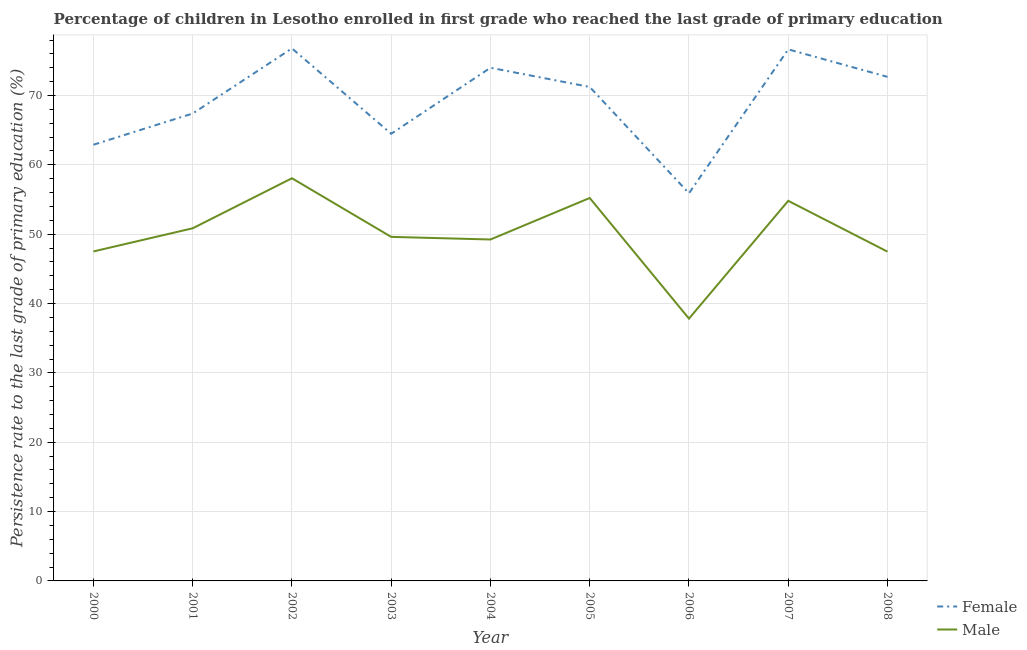Does the line corresponding to persistence rate of male students intersect with the line corresponding to persistence rate of female students?
Provide a short and direct response. No. Is the number of lines equal to the number of legend labels?
Your answer should be very brief. Yes. What is the persistence rate of male students in 2003?
Provide a succinct answer. 49.61. Across all years, what is the maximum persistence rate of female students?
Provide a succinct answer. 76.79. Across all years, what is the minimum persistence rate of female students?
Make the answer very short. 55.9. In which year was the persistence rate of male students maximum?
Your answer should be compact. 2002. In which year was the persistence rate of female students minimum?
Your response must be concise. 2006. What is the total persistence rate of female students in the graph?
Your response must be concise. 622.06. What is the difference between the persistence rate of male students in 2000 and that in 2008?
Keep it short and to the point. 0.03. What is the difference between the persistence rate of female students in 2004 and the persistence rate of male students in 2006?
Make the answer very short. 36.18. What is the average persistence rate of male students per year?
Provide a short and direct response. 50.07. In the year 2008, what is the difference between the persistence rate of female students and persistence rate of male students?
Your response must be concise. 25.2. In how many years, is the persistence rate of male students greater than 60 %?
Your answer should be compact. 0. What is the ratio of the persistence rate of female students in 2000 to that in 2008?
Your response must be concise. 0.87. Is the persistence rate of male students in 2002 less than that in 2003?
Provide a short and direct response. No. What is the difference between the highest and the second highest persistence rate of female students?
Your answer should be compact. 0.14. What is the difference between the highest and the lowest persistence rate of male students?
Give a very brief answer. 20.24. Does the persistence rate of female students monotonically increase over the years?
Provide a succinct answer. No. Is the persistence rate of male students strictly greater than the persistence rate of female students over the years?
Your answer should be very brief. No. Is the persistence rate of female students strictly less than the persistence rate of male students over the years?
Make the answer very short. No. How many years are there in the graph?
Make the answer very short. 9. What is the difference between two consecutive major ticks on the Y-axis?
Offer a very short reply. 10. Are the values on the major ticks of Y-axis written in scientific E-notation?
Give a very brief answer. No. Does the graph contain any zero values?
Your answer should be very brief. No. Where does the legend appear in the graph?
Offer a terse response. Bottom right. How many legend labels are there?
Make the answer very short. 2. What is the title of the graph?
Provide a short and direct response. Percentage of children in Lesotho enrolled in first grade who reached the last grade of primary education. Does "Investments" appear as one of the legend labels in the graph?
Your response must be concise. No. What is the label or title of the Y-axis?
Make the answer very short. Persistence rate to the last grade of primary education (%). What is the Persistence rate to the last grade of primary education (%) in Female in 2000?
Give a very brief answer. 62.9. What is the Persistence rate to the last grade of primary education (%) of Male in 2000?
Ensure brevity in your answer.  47.51. What is the Persistence rate to the last grade of primary education (%) in Female in 2001?
Provide a short and direct response. 67.4. What is the Persistence rate to the last grade of primary education (%) in Male in 2001?
Your answer should be compact. 50.85. What is the Persistence rate to the last grade of primary education (%) in Female in 2002?
Ensure brevity in your answer.  76.79. What is the Persistence rate to the last grade of primary education (%) of Male in 2002?
Offer a very short reply. 58.07. What is the Persistence rate to the last grade of primary education (%) in Female in 2003?
Offer a very short reply. 64.48. What is the Persistence rate to the last grade of primary education (%) of Male in 2003?
Make the answer very short. 49.61. What is the Persistence rate to the last grade of primary education (%) of Female in 2004?
Offer a terse response. 74. What is the Persistence rate to the last grade of primary education (%) of Male in 2004?
Offer a very short reply. 49.23. What is the Persistence rate to the last grade of primary education (%) of Female in 2005?
Your answer should be compact. 71.23. What is the Persistence rate to the last grade of primary education (%) of Male in 2005?
Your answer should be compact. 55.22. What is the Persistence rate to the last grade of primary education (%) of Female in 2006?
Offer a very short reply. 55.9. What is the Persistence rate to the last grade of primary education (%) in Male in 2006?
Make the answer very short. 37.83. What is the Persistence rate to the last grade of primary education (%) of Female in 2007?
Ensure brevity in your answer.  76.65. What is the Persistence rate to the last grade of primary education (%) in Male in 2007?
Offer a very short reply. 54.81. What is the Persistence rate to the last grade of primary education (%) in Female in 2008?
Offer a very short reply. 72.69. What is the Persistence rate to the last grade of primary education (%) in Male in 2008?
Offer a terse response. 47.48. Across all years, what is the maximum Persistence rate to the last grade of primary education (%) of Female?
Offer a terse response. 76.79. Across all years, what is the maximum Persistence rate to the last grade of primary education (%) in Male?
Your response must be concise. 58.07. Across all years, what is the minimum Persistence rate to the last grade of primary education (%) in Female?
Your response must be concise. 55.9. Across all years, what is the minimum Persistence rate to the last grade of primary education (%) of Male?
Offer a very short reply. 37.83. What is the total Persistence rate to the last grade of primary education (%) in Female in the graph?
Offer a very short reply. 622.06. What is the total Persistence rate to the last grade of primary education (%) of Male in the graph?
Make the answer very short. 450.63. What is the difference between the Persistence rate to the last grade of primary education (%) in Female in 2000 and that in 2001?
Offer a very short reply. -4.5. What is the difference between the Persistence rate to the last grade of primary education (%) in Male in 2000 and that in 2001?
Your answer should be very brief. -3.34. What is the difference between the Persistence rate to the last grade of primary education (%) of Female in 2000 and that in 2002?
Offer a terse response. -13.89. What is the difference between the Persistence rate to the last grade of primary education (%) in Male in 2000 and that in 2002?
Keep it short and to the point. -10.55. What is the difference between the Persistence rate to the last grade of primary education (%) in Female in 2000 and that in 2003?
Provide a succinct answer. -1.58. What is the difference between the Persistence rate to the last grade of primary education (%) in Male in 2000 and that in 2003?
Give a very brief answer. -2.1. What is the difference between the Persistence rate to the last grade of primary education (%) of Female in 2000 and that in 2004?
Offer a very short reply. -11.1. What is the difference between the Persistence rate to the last grade of primary education (%) of Male in 2000 and that in 2004?
Provide a succinct answer. -1.72. What is the difference between the Persistence rate to the last grade of primary education (%) of Female in 2000 and that in 2005?
Ensure brevity in your answer.  -8.33. What is the difference between the Persistence rate to the last grade of primary education (%) of Male in 2000 and that in 2005?
Give a very brief answer. -7.71. What is the difference between the Persistence rate to the last grade of primary education (%) in Female in 2000 and that in 2006?
Your response must be concise. 7. What is the difference between the Persistence rate to the last grade of primary education (%) in Male in 2000 and that in 2006?
Keep it short and to the point. 9.69. What is the difference between the Persistence rate to the last grade of primary education (%) in Female in 2000 and that in 2007?
Your answer should be very brief. -13.75. What is the difference between the Persistence rate to the last grade of primary education (%) of Male in 2000 and that in 2007?
Offer a terse response. -7.3. What is the difference between the Persistence rate to the last grade of primary education (%) in Female in 2000 and that in 2008?
Provide a short and direct response. -9.79. What is the difference between the Persistence rate to the last grade of primary education (%) in Male in 2000 and that in 2008?
Offer a terse response. 0.03. What is the difference between the Persistence rate to the last grade of primary education (%) in Female in 2001 and that in 2002?
Give a very brief answer. -9.39. What is the difference between the Persistence rate to the last grade of primary education (%) of Male in 2001 and that in 2002?
Make the answer very short. -7.22. What is the difference between the Persistence rate to the last grade of primary education (%) in Female in 2001 and that in 2003?
Give a very brief answer. 2.92. What is the difference between the Persistence rate to the last grade of primary education (%) in Male in 2001 and that in 2003?
Give a very brief answer. 1.24. What is the difference between the Persistence rate to the last grade of primary education (%) of Female in 2001 and that in 2004?
Offer a very short reply. -6.6. What is the difference between the Persistence rate to the last grade of primary education (%) in Male in 2001 and that in 2004?
Offer a terse response. 1.62. What is the difference between the Persistence rate to the last grade of primary education (%) in Female in 2001 and that in 2005?
Ensure brevity in your answer.  -3.83. What is the difference between the Persistence rate to the last grade of primary education (%) in Male in 2001 and that in 2005?
Provide a short and direct response. -4.37. What is the difference between the Persistence rate to the last grade of primary education (%) in Female in 2001 and that in 2006?
Provide a succinct answer. 11.5. What is the difference between the Persistence rate to the last grade of primary education (%) in Male in 2001 and that in 2006?
Offer a very short reply. 13.03. What is the difference between the Persistence rate to the last grade of primary education (%) of Female in 2001 and that in 2007?
Provide a short and direct response. -9.25. What is the difference between the Persistence rate to the last grade of primary education (%) of Male in 2001 and that in 2007?
Your response must be concise. -3.96. What is the difference between the Persistence rate to the last grade of primary education (%) in Female in 2001 and that in 2008?
Keep it short and to the point. -5.29. What is the difference between the Persistence rate to the last grade of primary education (%) in Male in 2001 and that in 2008?
Provide a short and direct response. 3.37. What is the difference between the Persistence rate to the last grade of primary education (%) of Female in 2002 and that in 2003?
Provide a succinct answer. 12.31. What is the difference between the Persistence rate to the last grade of primary education (%) of Male in 2002 and that in 2003?
Offer a very short reply. 8.45. What is the difference between the Persistence rate to the last grade of primary education (%) of Female in 2002 and that in 2004?
Your answer should be compact. 2.79. What is the difference between the Persistence rate to the last grade of primary education (%) of Male in 2002 and that in 2004?
Ensure brevity in your answer.  8.83. What is the difference between the Persistence rate to the last grade of primary education (%) in Female in 2002 and that in 2005?
Your answer should be very brief. 5.56. What is the difference between the Persistence rate to the last grade of primary education (%) of Male in 2002 and that in 2005?
Give a very brief answer. 2.85. What is the difference between the Persistence rate to the last grade of primary education (%) of Female in 2002 and that in 2006?
Provide a short and direct response. 20.89. What is the difference between the Persistence rate to the last grade of primary education (%) of Male in 2002 and that in 2006?
Make the answer very short. 20.24. What is the difference between the Persistence rate to the last grade of primary education (%) of Female in 2002 and that in 2007?
Offer a very short reply. 0.14. What is the difference between the Persistence rate to the last grade of primary education (%) in Male in 2002 and that in 2007?
Give a very brief answer. 3.25. What is the difference between the Persistence rate to the last grade of primary education (%) of Female in 2002 and that in 2008?
Give a very brief answer. 4.11. What is the difference between the Persistence rate to the last grade of primary education (%) of Male in 2002 and that in 2008?
Offer a terse response. 10.58. What is the difference between the Persistence rate to the last grade of primary education (%) in Female in 2003 and that in 2004?
Give a very brief answer. -9.52. What is the difference between the Persistence rate to the last grade of primary education (%) in Male in 2003 and that in 2004?
Give a very brief answer. 0.38. What is the difference between the Persistence rate to the last grade of primary education (%) in Female in 2003 and that in 2005?
Give a very brief answer. -6.75. What is the difference between the Persistence rate to the last grade of primary education (%) in Male in 2003 and that in 2005?
Your answer should be compact. -5.61. What is the difference between the Persistence rate to the last grade of primary education (%) in Female in 2003 and that in 2006?
Keep it short and to the point. 8.58. What is the difference between the Persistence rate to the last grade of primary education (%) of Male in 2003 and that in 2006?
Your answer should be very brief. 11.79. What is the difference between the Persistence rate to the last grade of primary education (%) of Female in 2003 and that in 2007?
Keep it short and to the point. -12.17. What is the difference between the Persistence rate to the last grade of primary education (%) in Male in 2003 and that in 2007?
Provide a short and direct response. -5.2. What is the difference between the Persistence rate to the last grade of primary education (%) in Female in 2003 and that in 2008?
Provide a succinct answer. -8.21. What is the difference between the Persistence rate to the last grade of primary education (%) of Male in 2003 and that in 2008?
Ensure brevity in your answer.  2.13. What is the difference between the Persistence rate to the last grade of primary education (%) in Female in 2004 and that in 2005?
Offer a terse response. 2.77. What is the difference between the Persistence rate to the last grade of primary education (%) of Male in 2004 and that in 2005?
Your answer should be compact. -5.99. What is the difference between the Persistence rate to the last grade of primary education (%) in Female in 2004 and that in 2006?
Your response must be concise. 18.1. What is the difference between the Persistence rate to the last grade of primary education (%) of Male in 2004 and that in 2006?
Ensure brevity in your answer.  11.41. What is the difference between the Persistence rate to the last grade of primary education (%) of Female in 2004 and that in 2007?
Provide a short and direct response. -2.65. What is the difference between the Persistence rate to the last grade of primary education (%) in Male in 2004 and that in 2007?
Give a very brief answer. -5.58. What is the difference between the Persistence rate to the last grade of primary education (%) in Female in 2004 and that in 2008?
Your answer should be compact. 1.31. What is the difference between the Persistence rate to the last grade of primary education (%) in Female in 2005 and that in 2006?
Your answer should be compact. 15.33. What is the difference between the Persistence rate to the last grade of primary education (%) in Male in 2005 and that in 2006?
Your answer should be very brief. 17.4. What is the difference between the Persistence rate to the last grade of primary education (%) of Female in 2005 and that in 2007?
Provide a succinct answer. -5.42. What is the difference between the Persistence rate to the last grade of primary education (%) of Male in 2005 and that in 2007?
Offer a terse response. 0.41. What is the difference between the Persistence rate to the last grade of primary education (%) of Female in 2005 and that in 2008?
Offer a terse response. -1.45. What is the difference between the Persistence rate to the last grade of primary education (%) in Male in 2005 and that in 2008?
Offer a very short reply. 7.74. What is the difference between the Persistence rate to the last grade of primary education (%) of Female in 2006 and that in 2007?
Give a very brief answer. -20.75. What is the difference between the Persistence rate to the last grade of primary education (%) in Male in 2006 and that in 2007?
Your response must be concise. -16.99. What is the difference between the Persistence rate to the last grade of primary education (%) of Female in 2006 and that in 2008?
Make the answer very short. -16.79. What is the difference between the Persistence rate to the last grade of primary education (%) in Male in 2006 and that in 2008?
Your answer should be compact. -9.66. What is the difference between the Persistence rate to the last grade of primary education (%) in Female in 2007 and that in 2008?
Provide a short and direct response. 3.97. What is the difference between the Persistence rate to the last grade of primary education (%) of Male in 2007 and that in 2008?
Keep it short and to the point. 7.33. What is the difference between the Persistence rate to the last grade of primary education (%) in Female in 2000 and the Persistence rate to the last grade of primary education (%) in Male in 2001?
Your answer should be very brief. 12.05. What is the difference between the Persistence rate to the last grade of primary education (%) in Female in 2000 and the Persistence rate to the last grade of primary education (%) in Male in 2002?
Your response must be concise. 4.83. What is the difference between the Persistence rate to the last grade of primary education (%) in Female in 2000 and the Persistence rate to the last grade of primary education (%) in Male in 2003?
Your answer should be compact. 13.29. What is the difference between the Persistence rate to the last grade of primary education (%) in Female in 2000 and the Persistence rate to the last grade of primary education (%) in Male in 2004?
Ensure brevity in your answer.  13.67. What is the difference between the Persistence rate to the last grade of primary education (%) in Female in 2000 and the Persistence rate to the last grade of primary education (%) in Male in 2005?
Your response must be concise. 7.68. What is the difference between the Persistence rate to the last grade of primary education (%) of Female in 2000 and the Persistence rate to the last grade of primary education (%) of Male in 2006?
Ensure brevity in your answer.  25.08. What is the difference between the Persistence rate to the last grade of primary education (%) in Female in 2000 and the Persistence rate to the last grade of primary education (%) in Male in 2007?
Provide a succinct answer. 8.09. What is the difference between the Persistence rate to the last grade of primary education (%) in Female in 2000 and the Persistence rate to the last grade of primary education (%) in Male in 2008?
Offer a terse response. 15.42. What is the difference between the Persistence rate to the last grade of primary education (%) in Female in 2001 and the Persistence rate to the last grade of primary education (%) in Male in 2002?
Ensure brevity in your answer.  9.33. What is the difference between the Persistence rate to the last grade of primary education (%) in Female in 2001 and the Persistence rate to the last grade of primary education (%) in Male in 2003?
Make the answer very short. 17.79. What is the difference between the Persistence rate to the last grade of primary education (%) in Female in 2001 and the Persistence rate to the last grade of primary education (%) in Male in 2004?
Give a very brief answer. 18.17. What is the difference between the Persistence rate to the last grade of primary education (%) in Female in 2001 and the Persistence rate to the last grade of primary education (%) in Male in 2005?
Give a very brief answer. 12.18. What is the difference between the Persistence rate to the last grade of primary education (%) in Female in 2001 and the Persistence rate to the last grade of primary education (%) in Male in 2006?
Offer a very short reply. 29.58. What is the difference between the Persistence rate to the last grade of primary education (%) in Female in 2001 and the Persistence rate to the last grade of primary education (%) in Male in 2007?
Your response must be concise. 12.59. What is the difference between the Persistence rate to the last grade of primary education (%) of Female in 2001 and the Persistence rate to the last grade of primary education (%) of Male in 2008?
Offer a terse response. 19.92. What is the difference between the Persistence rate to the last grade of primary education (%) in Female in 2002 and the Persistence rate to the last grade of primary education (%) in Male in 2003?
Your answer should be very brief. 27.18. What is the difference between the Persistence rate to the last grade of primary education (%) in Female in 2002 and the Persistence rate to the last grade of primary education (%) in Male in 2004?
Keep it short and to the point. 27.56. What is the difference between the Persistence rate to the last grade of primary education (%) of Female in 2002 and the Persistence rate to the last grade of primary education (%) of Male in 2005?
Your answer should be very brief. 21.57. What is the difference between the Persistence rate to the last grade of primary education (%) of Female in 2002 and the Persistence rate to the last grade of primary education (%) of Male in 2006?
Give a very brief answer. 38.97. What is the difference between the Persistence rate to the last grade of primary education (%) of Female in 2002 and the Persistence rate to the last grade of primary education (%) of Male in 2007?
Keep it short and to the point. 21.98. What is the difference between the Persistence rate to the last grade of primary education (%) in Female in 2002 and the Persistence rate to the last grade of primary education (%) in Male in 2008?
Your answer should be very brief. 29.31. What is the difference between the Persistence rate to the last grade of primary education (%) of Female in 2003 and the Persistence rate to the last grade of primary education (%) of Male in 2004?
Your response must be concise. 15.25. What is the difference between the Persistence rate to the last grade of primary education (%) in Female in 2003 and the Persistence rate to the last grade of primary education (%) in Male in 2005?
Keep it short and to the point. 9.26. What is the difference between the Persistence rate to the last grade of primary education (%) of Female in 2003 and the Persistence rate to the last grade of primary education (%) of Male in 2006?
Provide a succinct answer. 26.66. What is the difference between the Persistence rate to the last grade of primary education (%) in Female in 2003 and the Persistence rate to the last grade of primary education (%) in Male in 2007?
Give a very brief answer. 9.67. What is the difference between the Persistence rate to the last grade of primary education (%) of Female in 2003 and the Persistence rate to the last grade of primary education (%) of Male in 2008?
Keep it short and to the point. 17. What is the difference between the Persistence rate to the last grade of primary education (%) in Female in 2004 and the Persistence rate to the last grade of primary education (%) in Male in 2005?
Keep it short and to the point. 18.78. What is the difference between the Persistence rate to the last grade of primary education (%) in Female in 2004 and the Persistence rate to the last grade of primary education (%) in Male in 2006?
Provide a succinct answer. 36.18. What is the difference between the Persistence rate to the last grade of primary education (%) in Female in 2004 and the Persistence rate to the last grade of primary education (%) in Male in 2007?
Offer a terse response. 19.19. What is the difference between the Persistence rate to the last grade of primary education (%) of Female in 2004 and the Persistence rate to the last grade of primary education (%) of Male in 2008?
Give a very brief answer. 26.52. What is the difference between the Persistence rate to the last grade of primary education (%) of Female in 2005 and the Persistence rate to the last grade of primary education (%) of Male in 2006?
Ensure brevity in your answer.  33.41. What is the difference between the Persistence rate to the last grade of primary education (%) of Female in 2005 and the Persistence rate to the last grade of primary education (%) of Male in 2007?
Provide a short and direct response. 16.42. What is the difference between the Persistence rate to the last grade of primary education (%) of Female in 2005 and the Persistence rate to the last grade of primary education (%) of Male in 2008?
Provide a succinct answer. 23.75. What is the difference between the Persistence rate to the last grade of primary education (%) in Female in 2006 and the Persistence rate to the last grade of primary education (%) in Male in 2007?
Your answer should be very brief. 1.09. What is the difference between the Persistence rate to the last grade of primary education (%) in Female in 2006 and the Persistence rate to the last grade of primary education (%) in Male in 2008?
Offer a terse response. 8.42. What is the difference between the Persistence rate to the last grade of primary education (%) of Female in 2007 and the Persistence rate to the last grade of primary education (%) of Male in 2008?
Offer a terse response. 29.17. What is the average Persistence rate to the last grade of primary education (%) of Female per year?
Offer a very short reply. 69.12. What is the average Persistence rate to the last grade of primary education (%) of Male per year?
Provide a short and direct response. 50.07. In the year 2000, what is the difference between the Persistence rate to the last grade of primary education (%) of Female and Persistence rate to the last grade of primary education (%) of Male?
Your answer should be compact. 15.39. In the year 2001, what is the difference between the Persistence rate to the last grade of primary education (%) of Female and Persistence rate to the last grade of primary education (%) of Male?
Give a very brief answer. 16.55. In the year 2002, what is the difference between the Persistence rate to the last grade of primary education (%) in Female and Persistence rate to the last grade of primary education (%) in Male?
Your response must be concise. 18.73. In the year 2003, what is the difference between the Persistence rate to the last grade of primary education (%) in Female and Persistence rate to the last grade of primary education (%) in Male?
Ensure brevity in your answer.  14.87. In the year 2004, what is the difference between the Persistence rate to the last grade of primary education (%) of Female and Persistence rate to the last grade of primary education (%) of Male?
Give a very brief answer. 24.77. In the year 2005, what is the difference between the Persistence rate to the last grade of primary education (%) in Female and Persistence rate to the last grade of primary education (%) in Male?
Offer a terse response. 16.01. In the year 2006, what is the difference between the Persistence rate to the last grade of primary education (%) in Female and Persistence rate to the last grade of primary education (%) in Male?
Make the answer very short. 18.08. In the year 2007, what is the difference between the Persistence rate to the last grade of primary education (%) of Female and Persistence rate to the last grade of primary education (%) of Male?
Make the answer very short. 21.84. In the year 2008, what is the difference between the Persistence rate to the last grade of primary education (%) of Female and Persistence rate to the last grade of primary education (%) of Male?
Your answer should be compact. 25.2. What is the ratio of the Persistence rate to the last grade of primary education (%) of Female in 2000 to that in 2001?
Keep it short and to the point. 0.93. What is the ratio of the Persistence rate to the last grade of primary education (%) of Male in 2000 to that in 2001?
Offer a terse response. 0.93. What is the ratio of the Persistence rate to the last grade of primary education (%) in Female in 2000 to that in 2002?
Your answer should be very brief. 0.82. What is the ratio of the Persistence rate to the last grade of primary education (%) in Male in 2000 to that in 2002?
Keep it short and to the point. 0.82. What is the ratio of the Persistence rate to the last grade of primary education (%) of Female in 2000 to that in 2003?
Keep it short and to the point. 0.98. What is the ratio of the Persistence rate to the last grade of primary education (%) of Male in 2000 to that in 2003?
Make the answer very short. 0.96. What is the ratio of the Persistence rate to the last grade of primary education (%) in Female in 2000 to that in 2005?
Offer a terse response. 0.88. What is the ratio of the Persistence rate to the last grade of primary education (%) of Male in 2000 to that in 2005?
Keep it short and to the point. 0.86. What is the ratio of the Persistence rate to the last grade of primary education (%) in Female in 2000 to that in 2006?
Ensure brevity in your answer.  1.13. What is the ratio of the Persistence rate to the last grade of primary education (%) of Male in 2000 to that in 2006?
Provide a succinct answer. 1.26. What is the ratio of the Persistence rate to the last grade of primary education (%) of Female in 2000 to that in 2007?
Ensure brevity in your answer.  0.82. What is the ratio of the Persistence rate to the last grade of primary education (%) in Male in 2000 to that in 2007?
Keep it short and to the point. 0.87. What is the ratio of the Persistence rate to the last grade of primary education (%) of Female in 2000 to that in 2008?
Make the answer very short. 0.87. What is the ratio of the Persistence rate to the last grade of primary education (%) of Male in 2000 to that in 2008?
Provide a short and direct response. 1. What is the ratio of the Persistence rate to the last grade of primary education (%) of Female in 2001 to that in 2002?
Provide a succinct answer. 0.88. What is the ratio of the Persistence rate to the last grade of primary education (%) in Male in 2001 to that in 2002?
Keep it short and to the point. 0.88. What is the ratio of the Persistence rate to the last grade of primary education (%) of Female in 2001 to that in 2003?
Offer a terse response. 1.05. What is the ratio of the Persistence rate to the last grade of primary education (%) in Male in 2001 to that in 2003?
Your answer should be very brief. 1.02. What is the ratio of the Persistence rate to the last grade of primary education (%) in Female in 2001 to that in 2004?
Your response must be concise. 0.91. What is the ratio of the Persistence rate to the last grade of primary education (%) of Male in 2001 to that in 2004?
Offer a very short reply. 1.03. What is the ratio of the Persistence rate to the last grade of primary education (%) in Female in 2001 to that in 2005?
Offer a terse response. 0.95. What is the ratio of the Persistence rate to the last grade of primary education (%) in Male in 2001 to that in 2005?
Your answer should be very brief. 0.92. What is the ratio of the Persistence rate to the last grade of primary education (%) in Female in 2001 to that in 2006?
Your answer should be compact. 1.21. What is the ratio of the Persistence rate to the last grade of primary education (%) in Male in 2001 to that in 2006?
Offer a terse response. 1.34. What is the ratio of the Persistence rate to the last grade of primary education (%) in Female in 2001 to that in 2007?
Your response must be concise. 0.88. What is the ratio of the Persistence rate to the last grade of primary education (%) in Male in 2001 to that in 2007?
Provide a short and direct response. 0.93. What is the ratio of the Persistence rate to the last grade of primary education (%) of Female in 2001 to that in 2008?
Give a very brief answer. 0.93. What is the ratio of the Persistence rate to the last grade of primary education (%) of Male in 2001 to that in 2008?
Keep it short and to the point. 1.07. What is the ratio of the Persistence rate to the last grade of primary education (%) in Female in 2002 to that in 2003?
Your response must be concise. 1.19. What is the ratio of the Persistence rate to the last grade of primary education (%) of Male in 2002 to that in 2003?
Provide a succinct answer. 1.17. What is the ratio of the Persistence rate to the last grade of primary education (%) in Female in 2002 to that in 2004?
Keep it short and to the point. 1.04. What is the ratio of the Persistence rate to the last grade of primary education (%) in Male in 2002 to that in 2004?
Provide a succinct answer. 1.18. What is the ratio of the Persistence rate to the last grade of primary education (%) of Female in 2002 to that in 2005?
Make the answer very short. 1.08. What is the ratio of the Persistence rate to the last grade of primary education (%) in Male in 2002 to that in 2005?
Your response must be concise. 1.05. What is the ratio of the Persistence rate to the last grade of primary education (%) in Female in 2002 to that in 2006?
Offer a very short reply. 1.37. What is the ratio of the Persistence rate to the last grade of primary education (%) of Male in 2002 to that in 2006?
Your response must be concise. 1.54. What is the ratio of the Persistence rate to the last grade of primary education (%) of Female in 2002 to that in 2007?
Your answer should be very brief. 1. What is the ratio of the Persistence rate to the last grade of primary education (%) in Male in 2002 to that in 2007?
Provide a short and direct response. 1.06. What is the ratio of the Persistence rate to the last grade of primary education (%) in Female in 2002 to that in 2008?
Offer a very short reply. 1.06. What is the ratio of the Persistence rate to the last grade of primary education (%) in Male in 2002 to that in 2008?
Give a very brief answer. 1.22. What is the ratio of the Persistence rate to the last grade of primary education (%) in Female in 2003 to that in 2004?
Keep it short and to the point. 0.87. What is the ratio of the Persistence rate to the last grade of primary education (%) in Male in 2003 to that in 2004?
Your answer should be compact. 1.01. What is the ratio of the Persistence rate to the last grade of primary education (%) in Female in 2003 to that in 2005?
Your answer should be compact. 0.91. What is the ratio of the Persistence rate to the last grade of primary education (%) of Male in 2003 to that in 2005?
Keep it short and to the point. 0.9. What is the ratio of the Persistence rate to the last grade of primary education (%) of Female in 2003 to that in 2006?
Provide a short and direct response. 1.15. What is the ratio of the Persistence rate to the last grade of primary education (%) of Male in 2003 to that in 2006?
Make the answer very short. 1.31. What is the ratio of the Persistence rate to the last grade of primary education (%) in Female in 2003 to that in 2007?
Ensure brevity in your answer.  0.84. What is the ratio of the Persistence rate to the last grade of primary education (%) in Male in 2003 to that in 2007?
Provide a succinct answer. 0.91. What is the ratio of the Persistence rate to the last grade of primary education (%) of Female in 2003 to that in 2008?
Offer a very short reply. 0.89. What is the ratio of the Persistence rate to the last grade of primary education (%) in Male in 2003 to that in 2008?
Offer a terse response. 1.04. What is the ratio of the Persistence rate to the last grade of primary education (%) in Female in 2004 to that in 2005?
Ensure brevity in your answer.  1.04. What is the ratio of the Persistence rate to the last grade of primary education (%) in Male in 2004 to that in 2005?
Make the answer very short. 0.89. What is the ratio of the Persistence rate to the last grade of primary education (%) in Female in 2004 to that in 2006?
Provide a short and direct response. 1.32. What is the ratio of the Persistence rate to the last grade of primary education (%) of Male in 2004 to that in 2006?
Your answer should be compact. 1.3. What is the ratio of the Persistence rate to the last grade of primary education (%) in Female in 2004 to that in 2007?
Your answer should be compact. 0.97. What is the ratio of the Persistence rate to the last grade of primary education (%) in Male in 2004 to that in 2007?
Your answer should be very brief. 0.9. What is the ratio of the Persistence rate to the last grade of primary education (%) of Female in 2004 to that in 2008?
Ensure brevity in your answer.  1.02. What is the ratio of the Persistence rate to the last grade of primary education (%) in Male in 2004 to that in 2008?
Offer a terse response. 1.04. What is the ratio of the Persistence rate to the last grade of primary education (%) of Female in 2005 to that in 2006?
Your response must be concise. 1.27. What is the ratio of the Persistence rate to the last grade of primary education (%) of Male in 2005 to that in 2006?
Your response must be concise. 1.46. What is the ratio of the Persistence rate to the last grade of primary education (%) in Female in 2005 to that in 2007?
Provide a short and direct response. 0.93. What is the ratio of the Persistence rate to the last grade of primary education (%) of Male in 2005 to that in 2007?
Keep it short and to the point. 1.01. What is the ratio of the Persistence rate to the last grade of primary education (%) of Female in 2005 to that in 2008?
Offer a terse response. 0.98. What is the ratio of the Persistence rate to the last grade of primary education (%) of Male in 2005 to that in 2008?
Provide a short and direct response. 1.16. What is the ratio of the Persistence rate to the last grade of primary education (%) in Female in 2006 to that in 2007?
Offer a very short reply. 0.73. What is the ratio of the Persistence rate to the last grade of primary education (%) in Male in 2006 to that in 2007?
Your answer should be compact. 0.69. What is the ratio of the Persistence rate to the last grade of primary education (%) of Female in 2006 to that in 2008?
Ensure brevity in your answer.  0.77. What is the ratio of the Persistence rate to the last grade of primary education (%) of Male in 2006 to that in 2008?
Ensure brevity in your answer.  0.8. What is the ratio of the Persistence rate to the last grade of primary education (%) in Female in 2007 to that in 2008?
Your answer should be very brief. 1.05. What is the ratio of the Persistence rate to the last grade of primary education (%) in Male in 2007 to that in 2008?
Offer a terse response. 1.15. What is the difference between the highest and the second highest Persistence rate to the last grade of primary education (%) of Female?
Keep it short and to the point. 0.14. What is the difference between the highest and the second highest Persistence rate to the last grade of primary education (%) of Male?
Provide a short and direct response. 2.85. What is the difference between the highest and the lowest Persistence rate to the last grade of primary education (%) in Female?
Ensure brevity in your answer.  20.89. What is the difference between the highest and the lowest Persistence rate to the last grade of primary education (%) in Male?
Your answer should be compact. 20.24. 